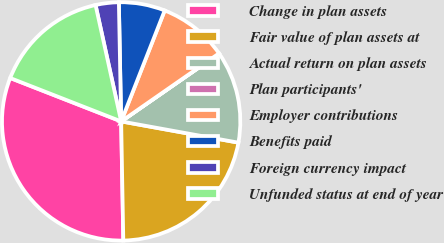<chart> <loc_0><loc_0><loc_500><loc_500><pie_chart><fcel>Change in plan assets<fcel>Fair value of plan assets at<fcel>Actual return on plan assets<fcel>Plan participants'<fcel>Employer contributions<fcel>Benefits paid<fcel>Foreign currency impact<fcel>Unfunded status at end of year<nl><fcel>31.22%<fcel>21.86%<fcel>12.5%<fcel>0.02%<fcel>9.38%<fcel>6.26%<fcel>3.14%<fcel>15.62%<nl></chart> 